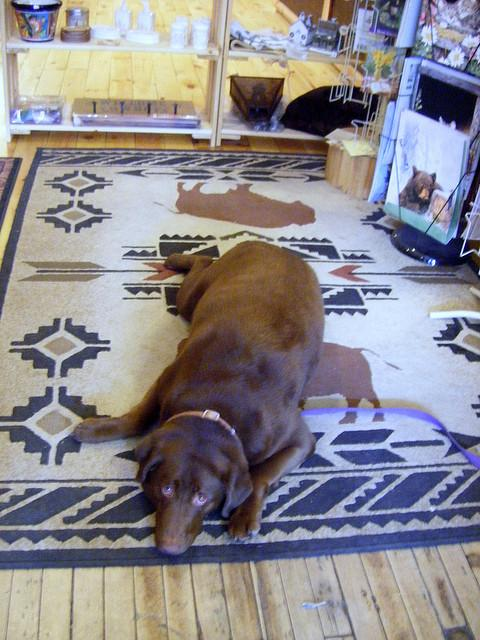What kind of dog is laying on the carpet? Please explain your reasoning. brown lab. The dog has chocolatey fur. 